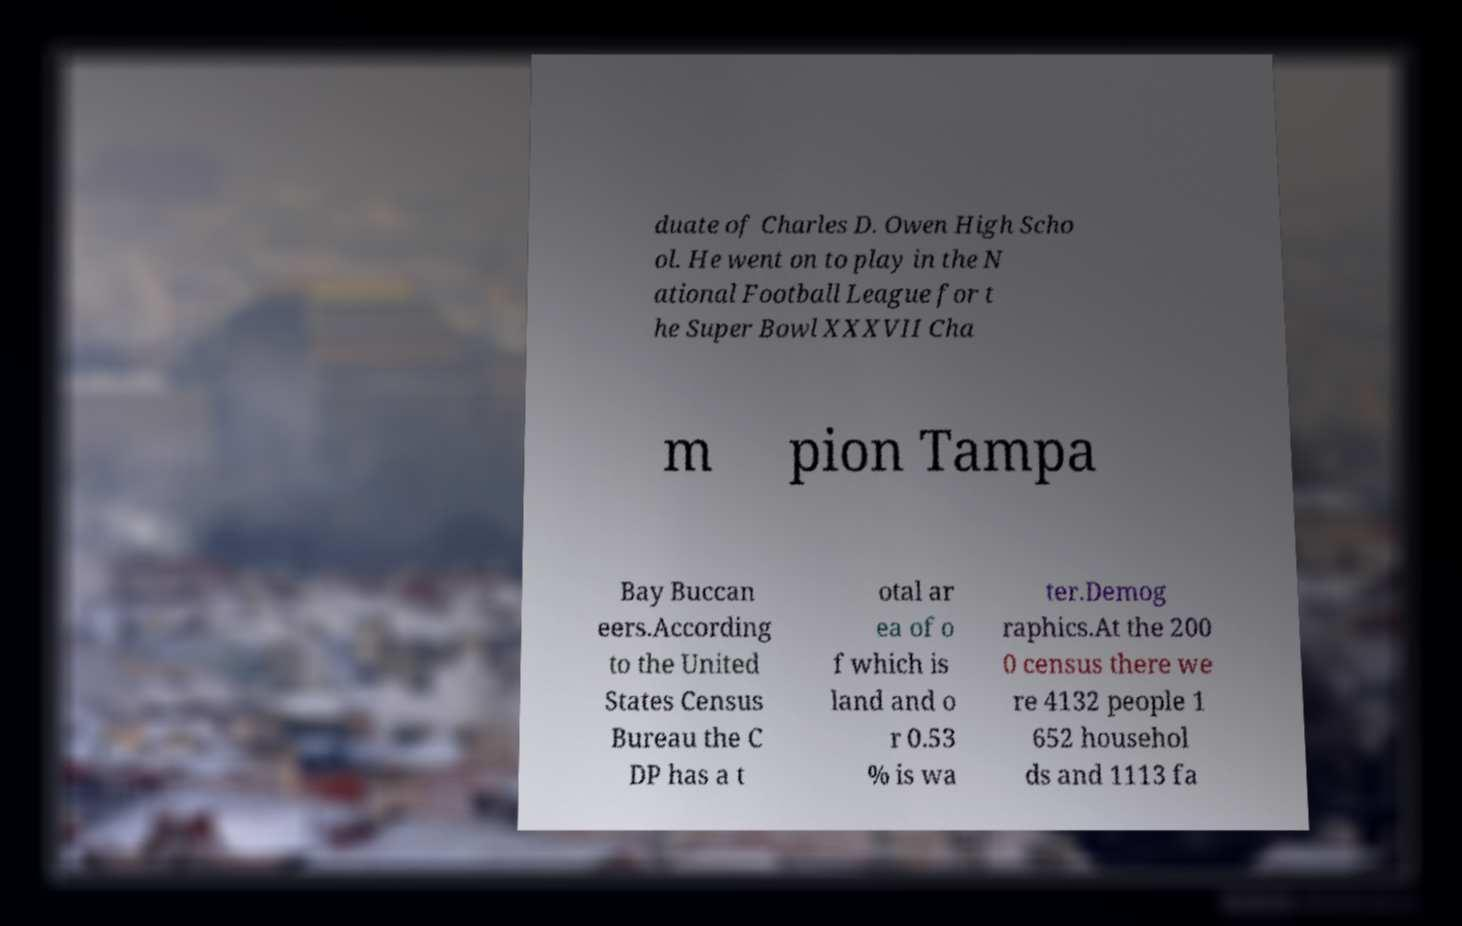I need the written content from this picture converted into text. Can you do that? duate of Charles D. Owen High Scho ol. He went on to play in the N ational Football League for t he Super Bowl XXXVII Cha m pion Tampa Bay Buccan eers.According to the United States Census Bureau the C DP has a t otal ar ea of o f which is land and o r 0.53 % is wa ter.Demog raphics.At the 200 0 census there we re 4132 people 1 652 househol ds and 1113 fa 